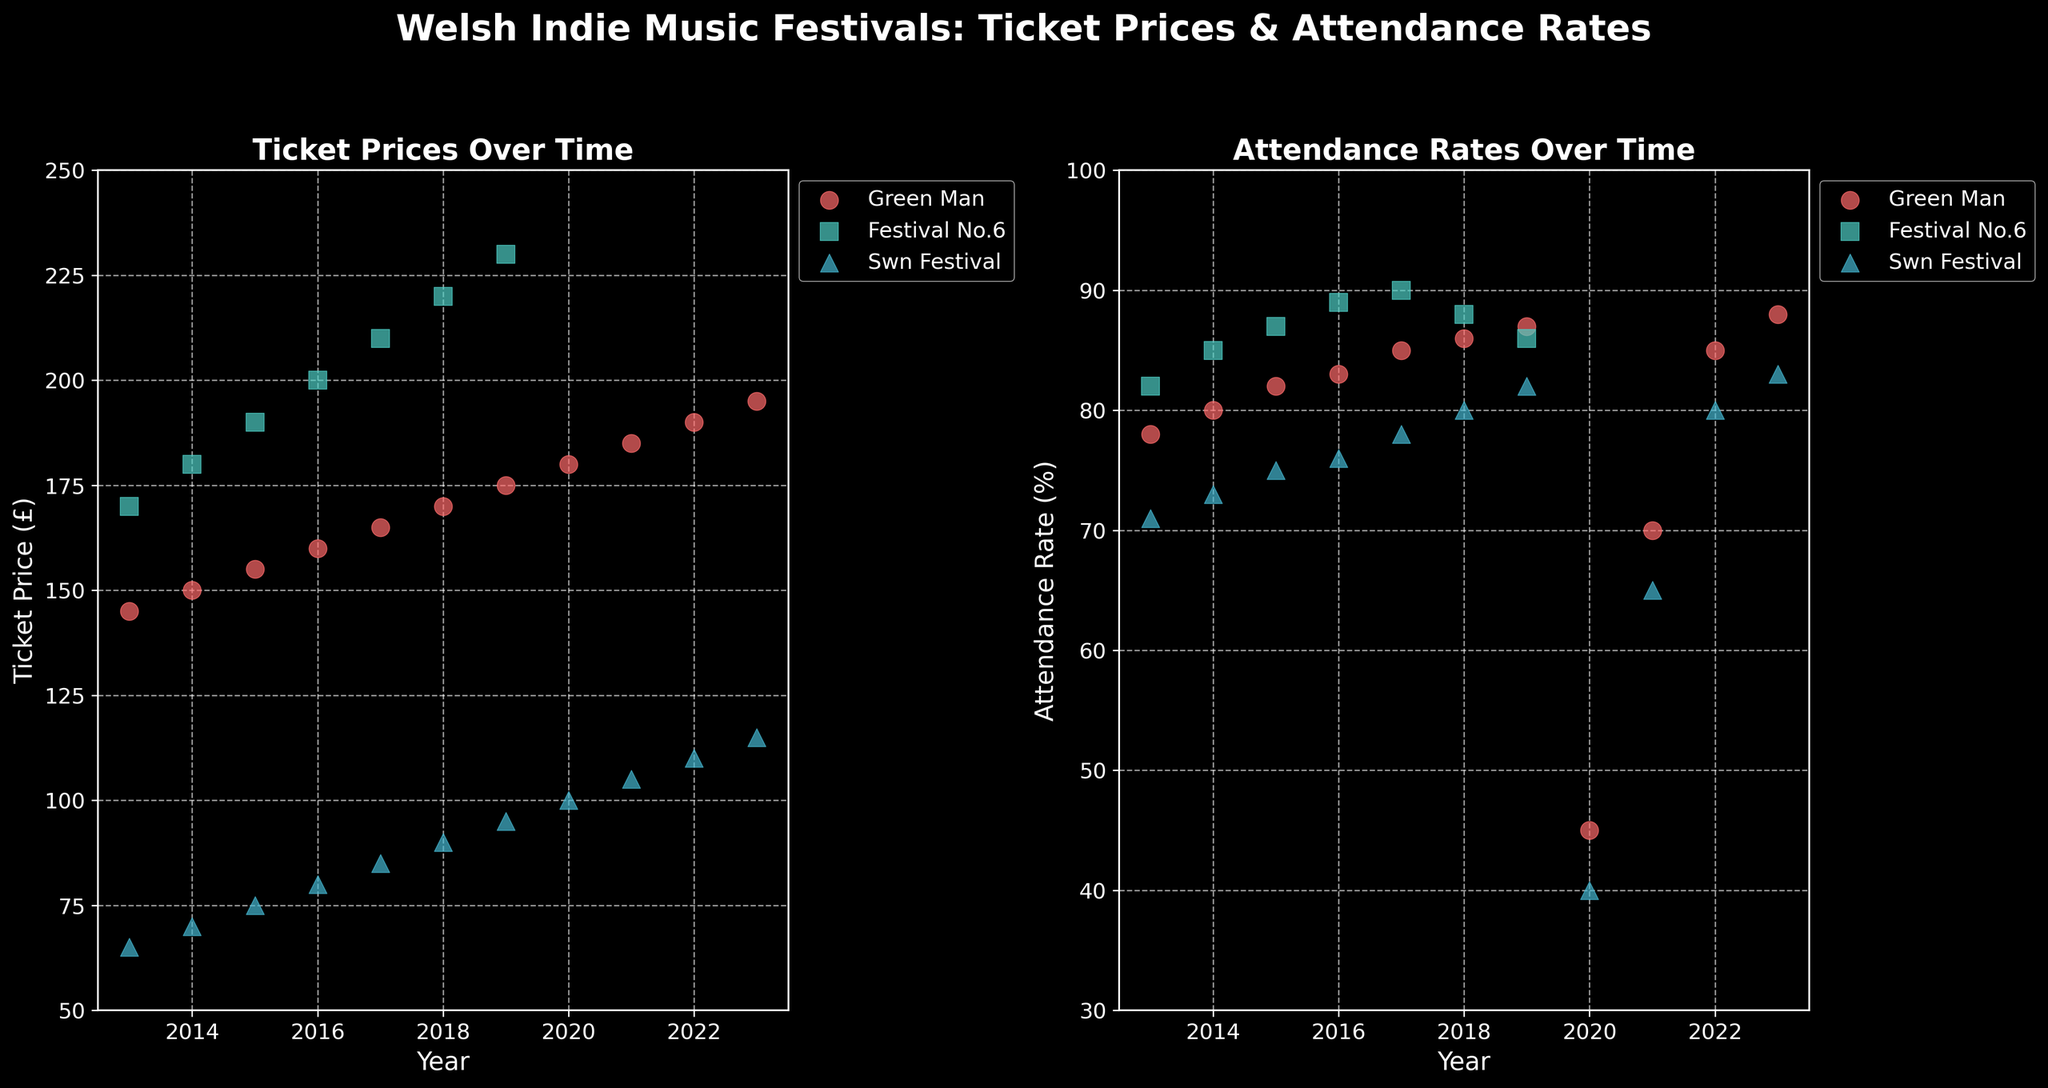What was the ticket price of Green Man in 2013 compared to 2023? For the year 2013, find the Green Man festival's ticket price, which is £145. For the year 2023, find the ticket price, which is £195. Compare these two values.
Answer: 145 vs 195 Which festival had the highest attendance rate in 2017? Look at the scatter plot for attendance rates in 2017 and identify the festival with the highest value. Festival No.6 had the highest rate of 90%.
Answer: Festival No.6 What is the trend in ticket prices for Swn Festival over the last decade? Examine the scatter plot for ticket prices for Swn Festival from 2013 to 2023. The prices increased consistently from £65 in 2013 to £115 in 2023.
Answer: Increasing In which year did Festival No.6 have the lowest attendance rate, and what was it? Review the scatter plot for attendance rates of Festival No.6 over the years and find the year with the lowest rate. 2019 had the lowest attendance rate of 86% for Festival No.6.
Answer: 2019, 86% Compare the attendance rates of Green Man and Swn Festival in 2022. Which was higher and by how much? Find the attendance rates for both Green Man and Swn Festival in 2022. Green Man had an attendance rate of 85%, while Swn Festival had 80%. The difference is 5%.
Answer: Green Man by 5% What impact did the pandemic (2020) seem to have on the attendance rates of Green Man and Swn Festival? Check the attendance rates for both festivals in 2020. Green Man had an attendance rate of 45%, and Swn Festival had 40%. Compare these to previous years' rates.
Answer: Decreased significantly What is the overall trend in attendance rates for the Green Man festival from 2013 to 2023? Evaluate the attendance rate data points for Green Man from 2013 to 2023. Attendance rates started at 78% in 2013, dipped significantly in 2020, but recovered to 88% in 2023.
Answer: Fluctuating, but overall positive trend Was there any year where the ticket price for Festival No.6 did not increase compared to the previous year? Compare the ticket prices of Festival No.6 for each year sequentially. The prices increased every year from 2013 to 2019.
Answer: No What is the difference in ticket price growth between the Green Man and Swn Festival from 2013 to 2023? Calculate the difference in ticket prices for both festivals between 2013 and 2023. Green Man increased from £145 to £195 (£50), and Swn Festival increased from £65 to £115 (£50). Both had the same growth.
Answer: Same (£50) How did the attendance rates of the festivals recover post-2020? Compare the attendance rates pre-2020, during 2020, and post-2020 for the festivals. Attendance rates were lower in 2020 but reached near or above pre-2020 levels by 2023.
Answer: Recovered to near or above pre-2020 levels 